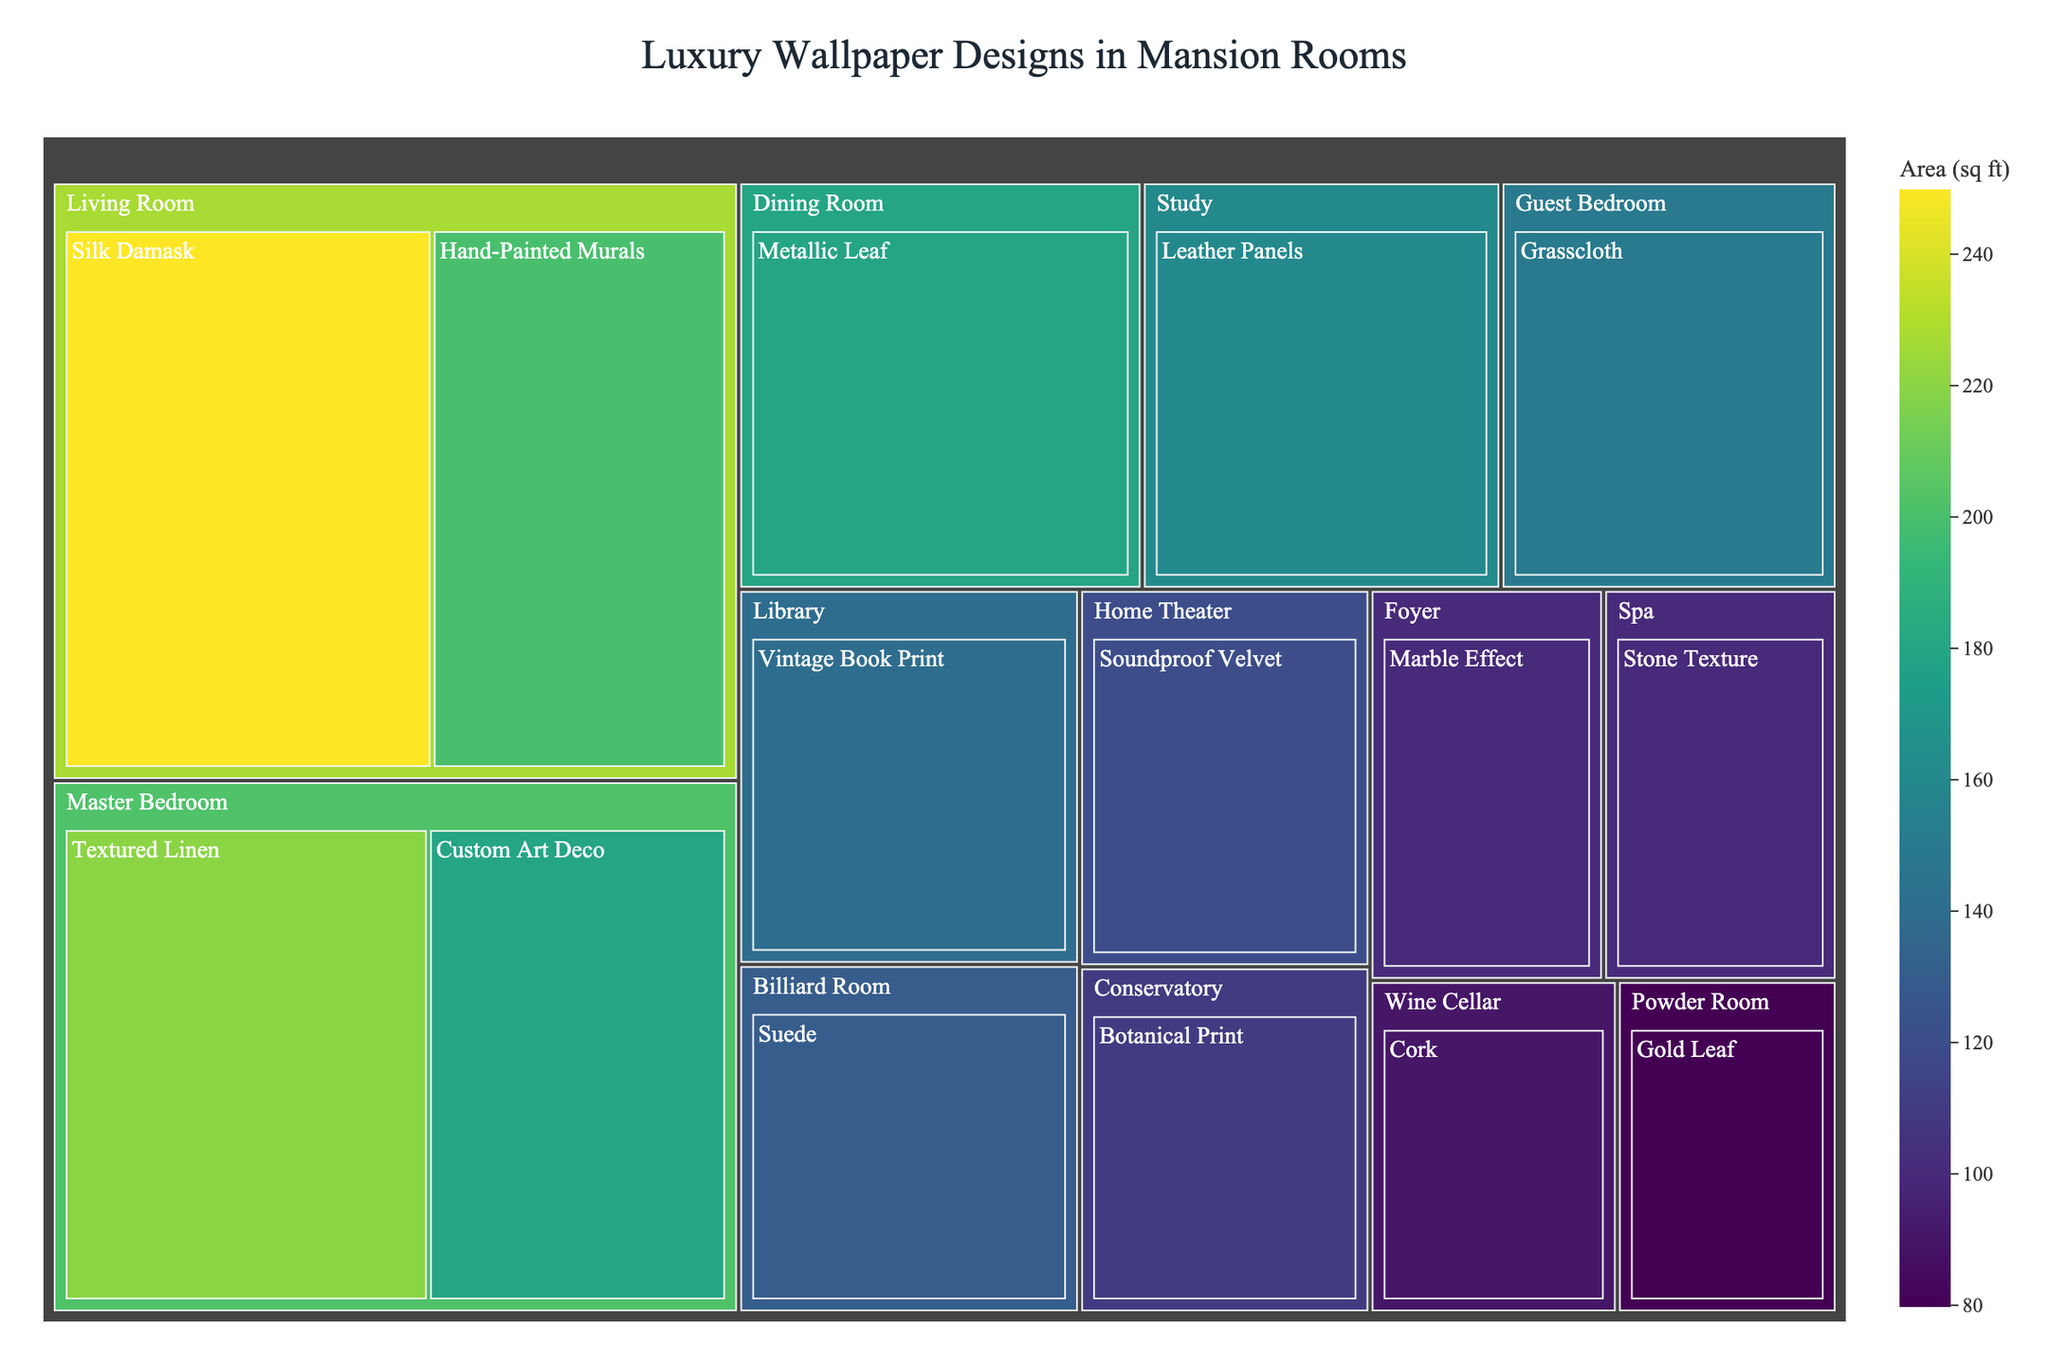What's the total area of wallpaper designs in the Living Room? Sum the area of Silk Damask (250 sq ft) and Hand-Painted Murals (200 sq ft) in the Living Room: 250 + 200 = 450
Answer: 450 sq ft Which room has the largest area allocated for wallpaper designs? Compare the total areas allocated for each room: Living Room (450), Dining Room (180), Master Bedroom (400), etc. The Living Room has the highest total area.
Answer: Living Room What's the average area of wallpaper designs in the Master Bedroom? Sum the area of Textured Linen (220 sq ft) and Custom Art Deco (180 sq ft) and divide by the number of categories (2): (220 + 180) / 2 = 200
Answer: 200 sq ft Which two rooms together have the smallest combined area for wallpaper designs? Add the areas of each pair of rooms and find the smallest sum: Powder Room (80) + Spa (100) = 180, which is the smallest combined area.
Answer: Powder Room and Spa What's the combined area of wallpaper designs in the Foyer and the Home Theater? Sum the area of Marble Effect in the Foyer (100 sq ft) and Soundproof Velvet in the Home Theater (120 sq ft): 100 + 120 = 220
Answer: 220 sq ft In which room is the Cork category wallpaper used? Locate the Cork category on the treemap and identify the corresponding room: Wine Cellar.
Answer: Wine Cellar What's the difference in area between the Guest Bedroom and the Study? Subtract the area of wallpaper in the Study (Leather Panels, 160 sq ft) from the area in the Guest Bedroom (Grasscloth, 150 sq ft): 150 - 160 = -10
Answer: -10 sq ft Which room features the Gold Leaf wallpaper design and what's its area? Identify the room labeled with Gold Leaf: Powder Room, and check the area: 80 sq ft.
Answer: Powder Room, 80 sq ft How many unique wallpaper categories are used across all rooms? Count the distinct wallpaper categories listed: Silk Damask, Hand-Painted Murals, Metallic Leaf, Textured Linen, Custom Art Deco, Grasscloth, Leather Panels, Vintage Book Print, Soundproof Velvet, Marble Effect, Gold Leaf, Cork, Botanical Print, Suede, Stone Texture. There are 15 unique categories.
Answer: 15 